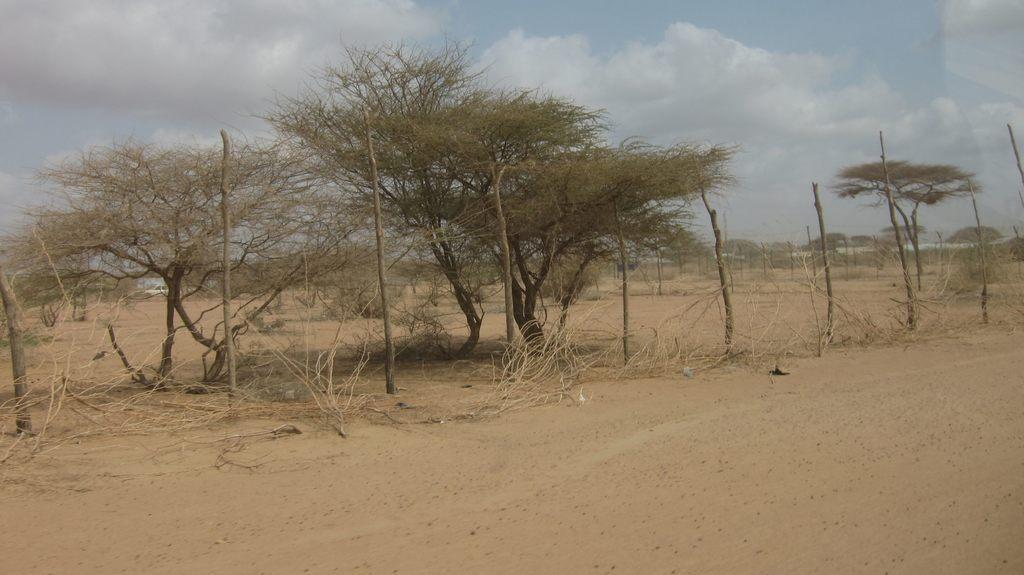Please provide a concise description of this image. In the picture there is a land and on the land there are wooden sticks and trees. 